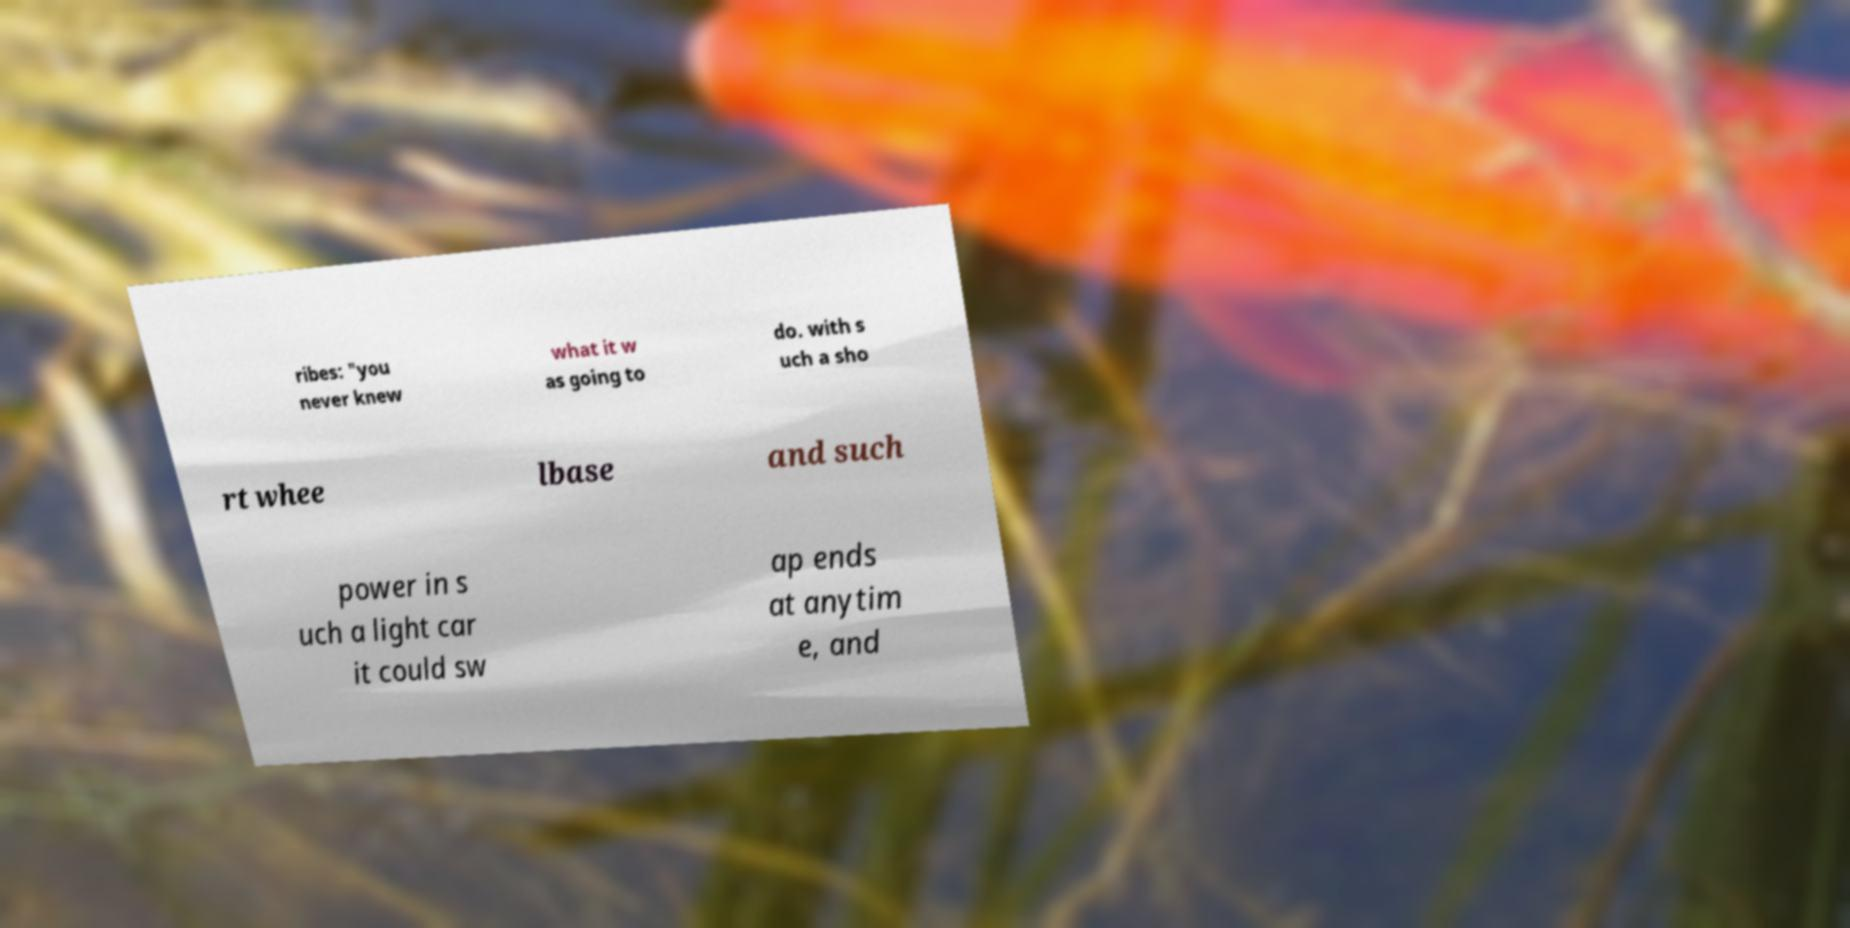Please read and relay the text visible in this image. What does it say? ribes: "you never knew what it w as going to do. with s uch a sho rt whee lbase and such power in s uch a light car it could sw ap ends at anytim e, and 